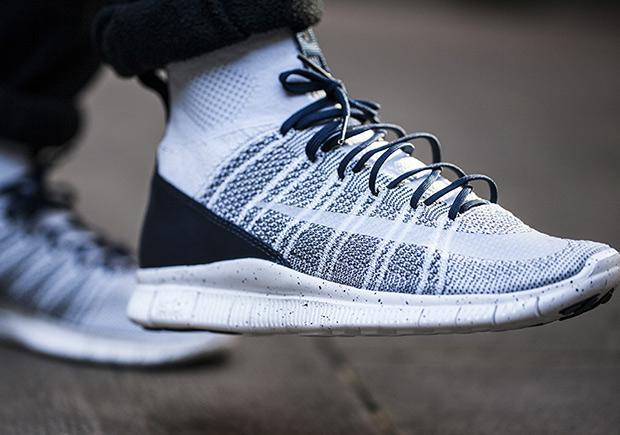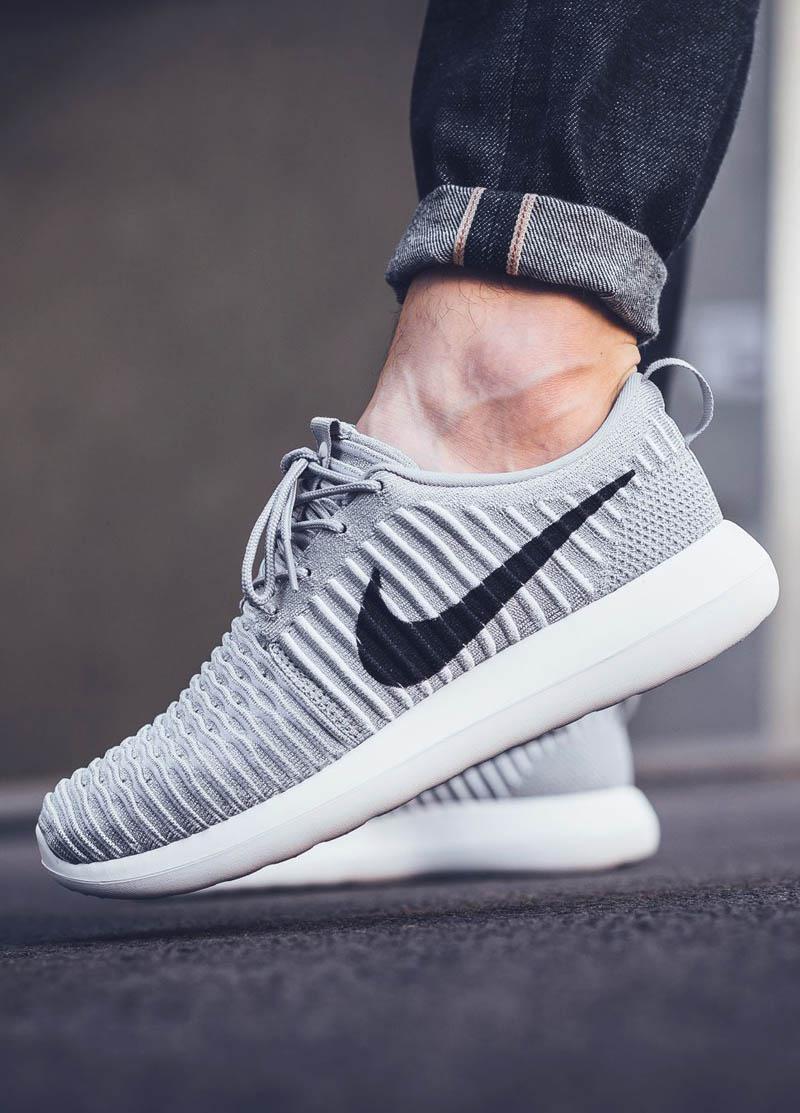The first image is the image on the left, the second image is the image on the right. Considering the images on both sides, is "The person in the image on the left is standing with both feet planted firmly a hard surface." valid? Answer yes or no. No. The first image is the image on the left, the second image is the image on the right. Considering the images on both sides, is "An image shows a pair of sneaker-wearing feet flat on the ground on an outdoor surface." valid? Answer yes or no. No. 